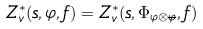<formula> <loc_0><loc_0><loc_500><loc_500>Z ^ { * } _ { v } ( s , \varphi , f ) = Z ^ { * } _ { v } ( s , \Phi _ { \varphi \otimes \overline { \varphi } } , f )</formula> 